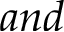Convert formula to latex. <formula><loc_0><loc_0><loc_500><loc_500>a n d</formula> 